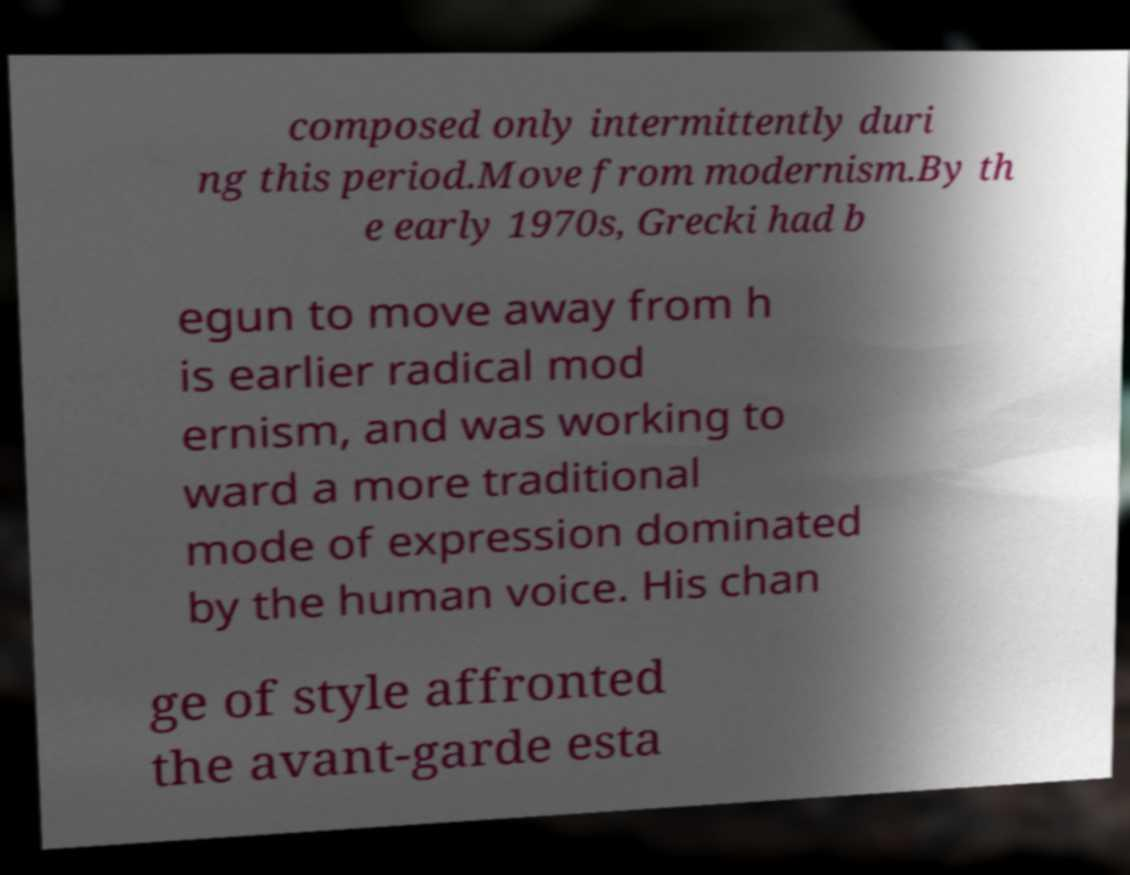Could you assist in decoding the text presented in this image and type it out clearly? composed only intermittently duri ng this period.Move from modernism.By th e early 1970s, Grecki had b egun to move away from h is earlier radical mod ernism, and was working to ward a more traditional mode of expression dominated by the human voice. His chan ge of style affronted the avant-garde esta 